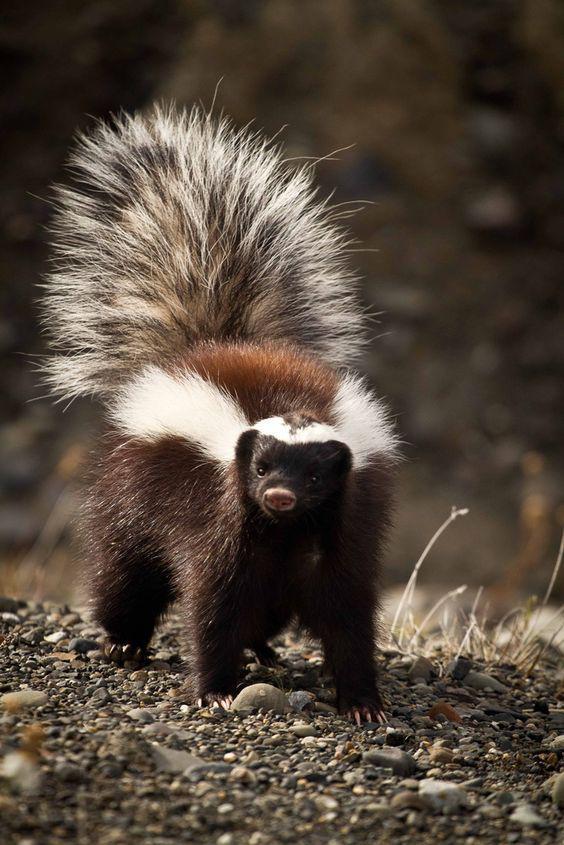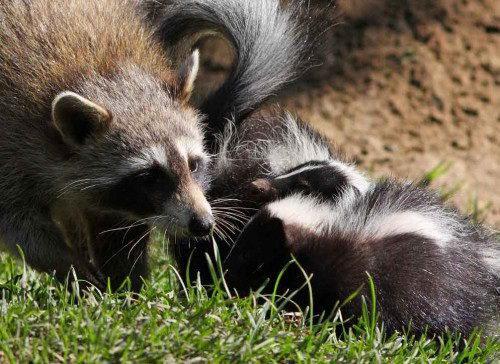The first image is the image on the left, the second image is the image on the right. Assess this claim about the two images: "In the left image there is a skunk and one other animal.". Correct or not? Answer yes or no. No. 